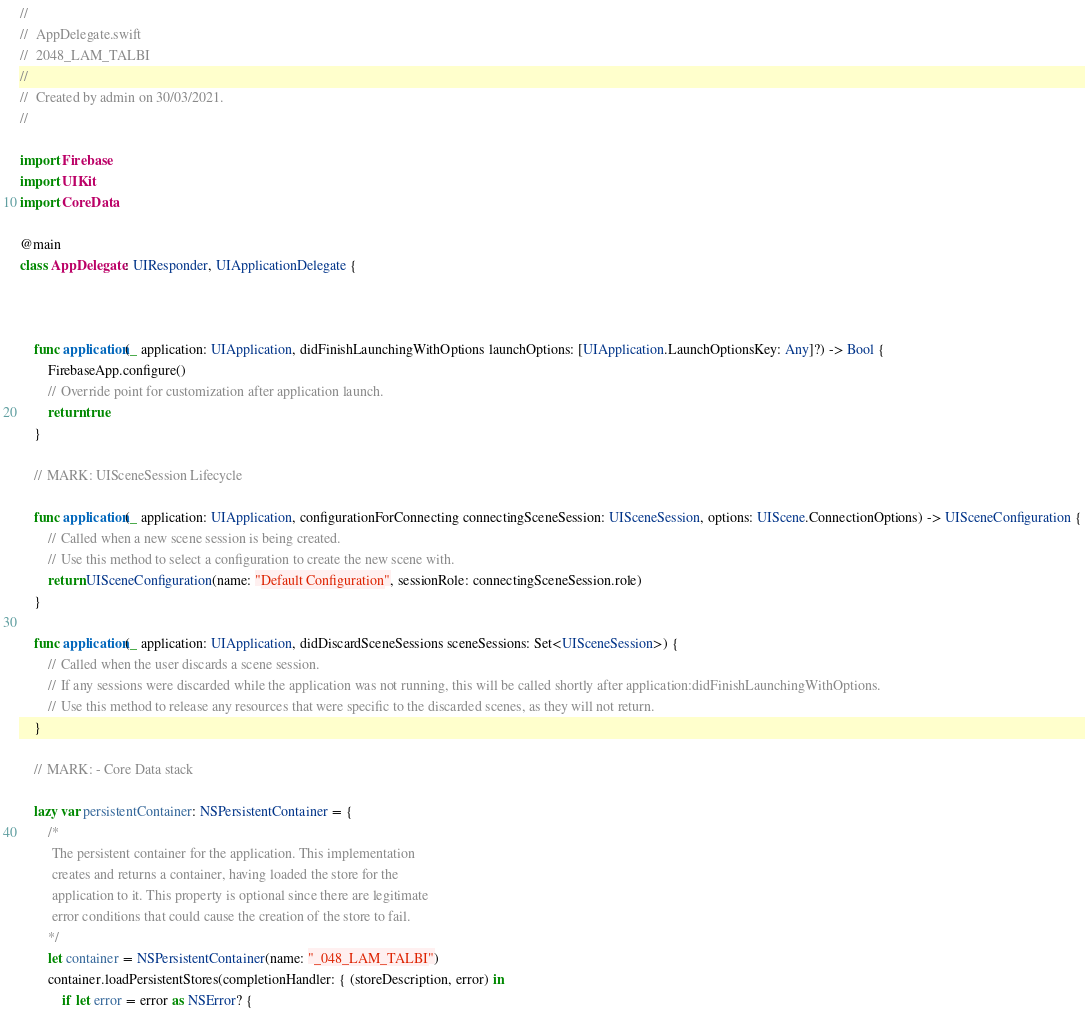Convert code to text. <code><loc_0><loc_0><loc_500><loc_500><_Swift_>//
//  AppDelegate.swift
//  2048_LAM_TALBI
//
//  Created by admin on 30/03/2021.
//

import Firebase
import UIKit
import CoreData

@main
class AppDelegate: UIResponder, UIApplicationDelegate {



    func application(_ application: UIApplication, didFinishLaunchingWithOptions launchOptions: [UIApplication.LaunchOptionsKey: Any]?) -> Bool {
        FirebaseApp.configure()
        // Override point for customization after application launch.
        return true
    }

    // MARK: UISceneSession Lifecycle

    func application(_ application: UIApplication, configurationForConnecting connectingSceneSession: UISceneSession, options: UIScene.ConnectionOptions) -> UISceneConfiguration {
        // Called when a new scene session is being created.
        // Use this method to select a configuration to create the new scene with.
        return UISceneConfiguration(name: "Default Configuration", sessionRole: connectingSceneSession.role)
    }

    func application(_ application: UIApplication, didDiscardSceneSessions sceneSessions: Set<UISceneSession>) {
        // Called when the user discards a scene session.
        // If any sessions were discarded while the application was not running, this will be called shortly after application:didFinishLaunchingWithOptions.
        // Use this method to release any resources that were specific to the discarded scenes, as they will not return.
    }

    // MARK: - Core Data stack

    lazy var persistentContainer: NSPersistentContainer = {
        /*
         The persistent container for the application. This implementation
         creates and returns a container, having loaded the store for the
         application to it. This property is optional since there are legitimate
         error conditions that could cause the creation of the store to fail.
        */
        let container = NSPersistentContainer(name: "_048_LAM_TALBI")
        container.loadPersistentStores(completionHandler: { (storeDescription, error) in
            if let error = error as NSError? {</code> 